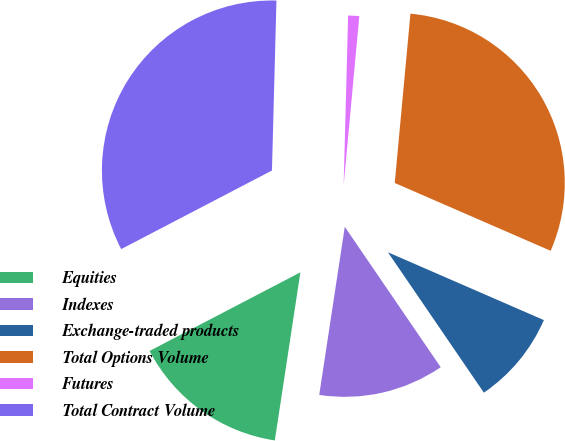<chart> <loc_0><loc_0><loc_500><loc_500><pie_chart><fcel>Equities<fcel>Indexes<fcel>Exchange-traded products<fcel>Total Options Volume<fcel>Futures<fcel>Total Contract Volume<nl><fcel>14.95%<fcel>11.94%<fcel>8.93%<fcel>30.06%<fcel>1.05%<fcel>33.07%<nl></chart> 